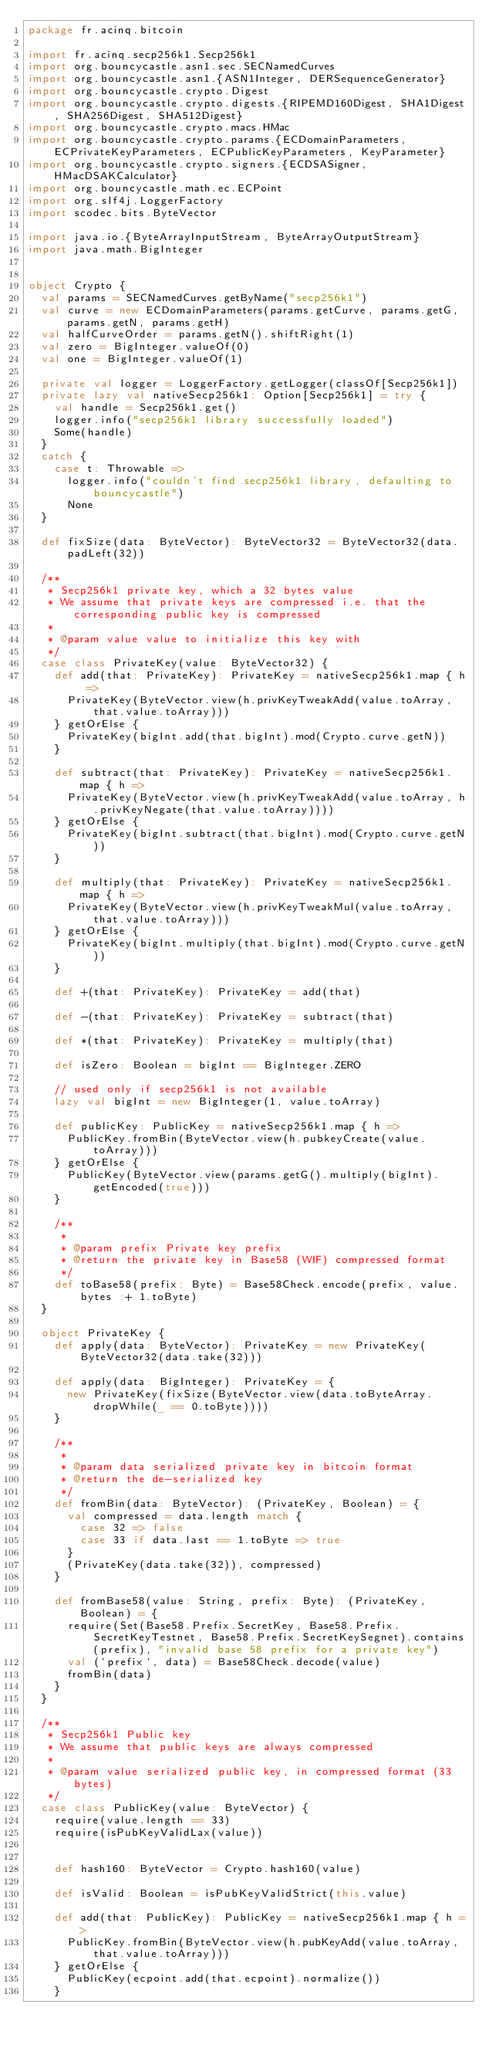<code> <loc_0><loc_0><loc_500><loc_500><_Scala_>package fr.acinq.bitcoin

import fr.acinq.secp256k1.Secp256k1
import org.bouncycastle.asn1.sec.SECNamedCurves
import org.bouncycastle.asn1.{ASN1Integer, DERSequenceGenerator}
import org.bouncycastle.crypto.Digest
import org.bouncycastle.crypto.digests.{RIPEMD160Digest, SHA1Digest, SHA256Digest, SHA512Digest}
import org.bouncycastle.crypto.macs.HMac
import org.bouncycastle.crypto.params.{ECDomainParameters, ECPrivateKeyParameters, ECPublicKeyParameters, KeyParameter}
import org.bouncycastle.crypto.signers.{ECDSASigner, HMacDSAKCalculator}
import org.bouncycastle.math.ec.ECPoint
import org.slf4j.LoggerFactory
import scodec.bits.ByteVector

import java.io.{ByteArrayInputStream, ByteArrayOutputStream}
import java.math.BigInteger


object Crypto {
  val params = SECNamedCurves.getByName("secp256k1")
  val curve = new ECDomainParameters(params.getCurve, params.getG, params.getN, params.getH)
  val halfCurveOrder = params.getN().shiftRight(1)
  val zero = BigInteger.valueOf(0)
  val one = BigInteger.valueOf(1)

  private val logger = LoggerFactory.getLogger(classOf[Secp256k1])
  private lazy val nativeSecp256k1: Option[Secp256k1] = try {
    val handle = Secp256k1.get()
    logger.info("secp256k1 library successfully loaded")
    Some(handle)
  }
  catch {
    case t: Throwable =>
      logger.info("couldn't find secp256k1 library, defaulting to bouncycastle")
      None
  }

  def fixSize(data: ByteVector): ByteVector32 = ByteVector32(data.padLeft(32))

  /**
   * Secp256k1 private key, which a 32 bytes value
   * We assume that private keys are compressed i.e. that the corresponding public key is compressed
   *
   * @param value value to initialize this key with
   */
  case class PrivateKey(value: ByteVector32) {
    def add(that: PrivateKey): PrivateKey = nativeSecp256k1.map { h =>
      PrivateKey(ByteVector.view(h.privKeyTweakAdd(value.toArray, that.value.toArray)))
    } getOrElse {
      PrivateKey(bigInt.add(that.bigInt).mod(Crypto.curve.getN))
    }

    def subtract(that: PrivateKey): PrivateKey = nativeSecp256k1.map { h =>
      PrivateKey(ByteVector.view(h.privKeyTweakAdd(value.toArray, h.privKeyNegate(that.value.toArray))))
    } getOrElse {
      PrivateKey(bigInt.subtract(that.bigInt).mod(Crypto.curve.getN))
    }

    def multiply(that: PrivateKey): PrivateKey = nativeSecp256k1.map { h =>
      PrivateKey(ByteVector.view(h.privKeyTweakMul(value.toArray, that.value.toArray)))
    } getOrElse {
      PrivateKey(bigInt.multiply(that.bigInt).mod(Crypto.curve.getN))
    }

    def +(that: PrivateKey): PrivateKey = add(that)

    def -(that: PrivateKey): PrivateKey = subtract(that)

    def *(that: PrivateKey): PrivateKey = multiply(that)

    def isZero: Boolean = bigInt == BigInteger.ZERO

    // used only if secp256k1 is not available
    lazy val bigInt = new BigInteger(1, value.toArray)

    def publicKey: PublicKey = nativeSecp256k1.map { h =>
      PublicKey.fromBin(ByteVector.view(h.pubkeyCreate(value.toArray)))
    } getOrElse {
      PublicKey(ByteVector.view(params.getG().multiply(bigInt).getEncoded(true)))
    }

    /**
     *
     * @param prefix Private key prefix
     * @return the private key in Base58 (WIF) compressed format
     */
    def toBase58(prefix: Byte) = Base58Check.encode(prefix, value.bytes :+ 1.toByte)
  }

  object PrivateKey {
    def apply(data: ByteVector): PrivateKey = new PrivateKey(ByteVector32(data.take(32)))

    def apply(data: BigInteger): PrivateKey = {
      new PrivateKey(fixSize(ByteVector.view(data.toByteArray.dropWhile(_ == 0.toByte))))
    }

    /**
     *
     * @param data serialized private key in bitcoin format
     * @return the de-serialized key
     */
    def fromBin(data: ByteVector): (PrivateKey, Boolean) = {
      val compressed = data.length match {
        case 32 => false
        case 33 if data.last == 1.toByte => true
      }
      (PrivateKey(data.take(32)), compressed)
    }

    def fromBase58(value: String, prefix: Byte): (PrivateKey, Boolean) = {
      require(Set(Base58.Prefix.SecretKey, Base58.Prefix.SecretKeyTestnet, Base58.Prefix.SecretKeySegnet).contains(prefix), "invalid base 58 prefix for a private key")
      val (`prefix`, data) = Base58Check.decode(value)
      fromBin(data)
    }
  }

  /**
   * Secp256k1 Public key
   * We assume that public keys are always compressed
   *
   * @param value serialized public key, in compressed format (33 bytes)
   */
  case class PublicKey(value: ByteVector) {
    require(value.length == 33)
    require(isPubKeyValidLax(value))


    def hash160: ByteVector = Crypto.hash160(value)

    def isValid: Boolean = isPubKeyValidStrict(this.value)

    def add(that: PublicKey): PublicKey = nativeSecp256k1.map { h =>
      PublicKey.fromBin(ByteVector.view(h.pubKeyAdd(value.toArray, that.value.toArray)))
    } getOrElse {
      PublicKey(ecpoint.add(that.ecpoint).normalize())
    }
</code> 